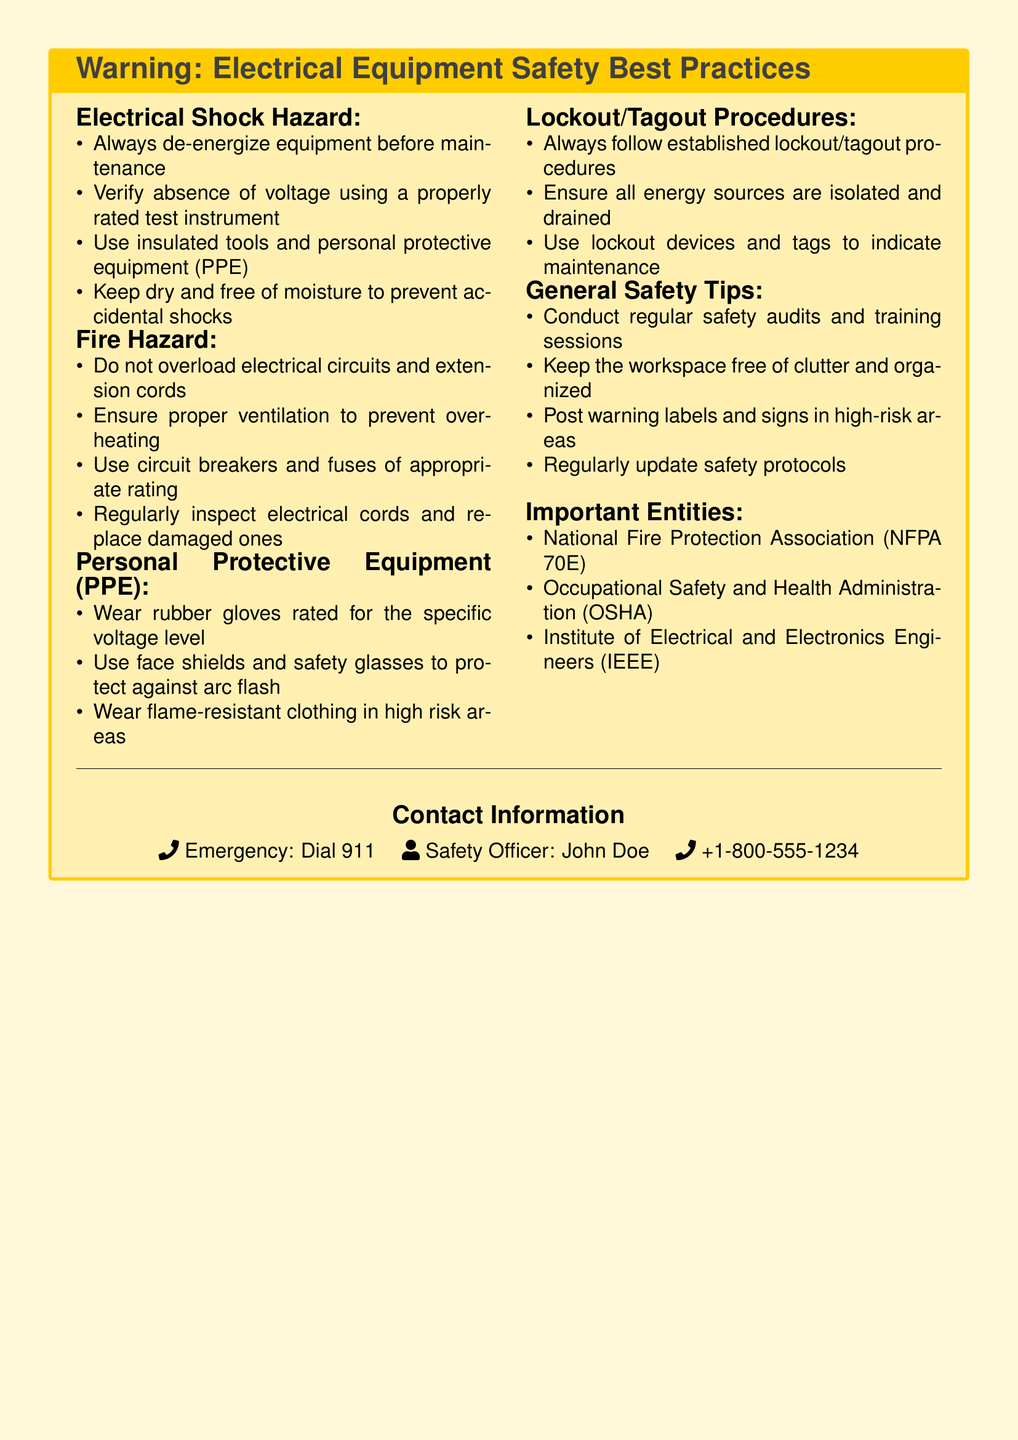What is the hazard associated with electrical shock? The section titled "Electrical Shock Hazard" lists various hazards and practices important for safety regarding electrical equipment.
Answer: Electrical Shock Hazard What should you wear to protect against arc flash? The "Personal Protective Equipment (PPE)" section provides recommendations on protective gear to wear in hazardous environments.
Answer: Face shields and safety glasses What is the first step before performing maintenance on electrical equipment? The "Electrical Shock Hazard" section emphasizes the importance of de-energizing equipment to ensure safety during maintenance.
Answer: De-energize equipment What should be done to prevent overloads in electrical systems? The "Fire Hazard" section specifically advises against overloading circuits and extension cords.
Answer: Do not overload electrical circuits What entity is mentioned as a reference for safety protocols? The "Important Entities" section lists organizations relevant to electrical safety standards.
Answer: National Fire Protection Association (NFPA 70E) How should energy sources be handled before maintenance according to safety practices? The "Lockout/Tagout Procedures" section specifies that all energy sources must be isolated and drained prior to maintenance.
Answer: Isolated and drained When conducting safety audits, what should you ensure regarding the workspace? The "General Safety Tips" section advises on workspace organization and cleanliness as part of safety measures.
Answer: Keep the workspace free of clutter What is the emergency contact number provided in the document? The contact information section includes an emergency number for immediate situations.
Answer: 911 